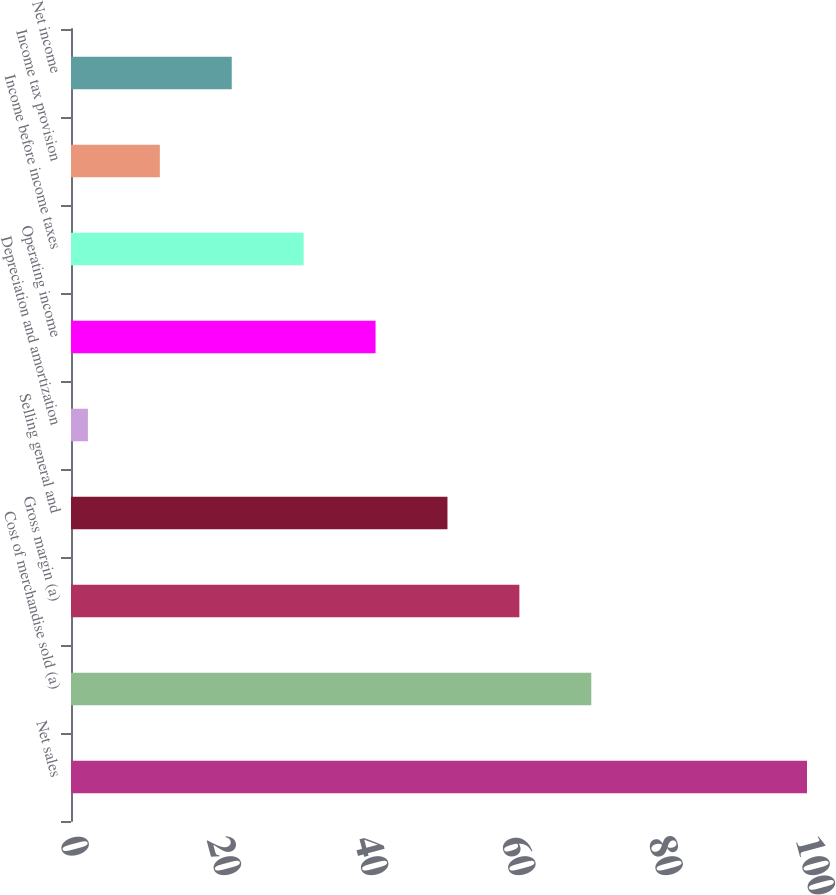<chart> <loc_0><loc_0><loc_500><loc_500><bar_chart><fcel>Net sales<fcel>Cost of merchandise sold (a)<fcel>Gross margin (a)<fcel>Selling general and<fcel>Depreciation and amortization<fcel>Operating income<fcel>Income before income taxes<fcel>Income tax provision<fcel>Net income<nl><fcel>100<fcel>70.69<fcel>60.92<fcel>51.15<fcel>2.3<fcel>41.38<fcel>31.61<fcel>12.07<fcel>21.84<nl></chart> 